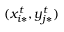<formula> <loc_0><loc_0><loc_500><loc_500>( x _ { i * } ^ { t } , y _ { j * } ^ { t } )</formula> 